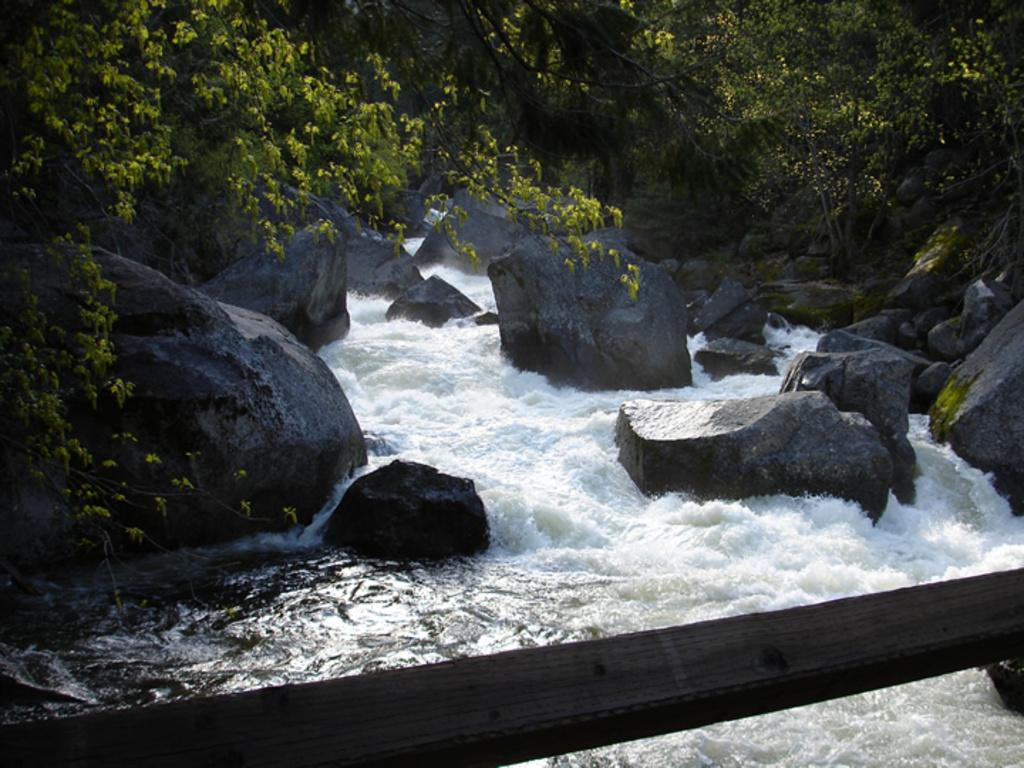What is located at the bottom of the image? There is a wooden pole at the bottom of the image. What can be seen in the background of the image? Water is flowing in the background of the image, and there are rocks and stones in the water. What type of vegetation is visible in the background of the image? Trees are visible in the background of the image. What type of shop can be seen in the image? There is no shop present in the image; it features a wooden pole, flowing water, rocks, stones, and trees. How does the wire affect the flow of water in the image? There is no wire present in the image, so it cannot affect the flow of water. 